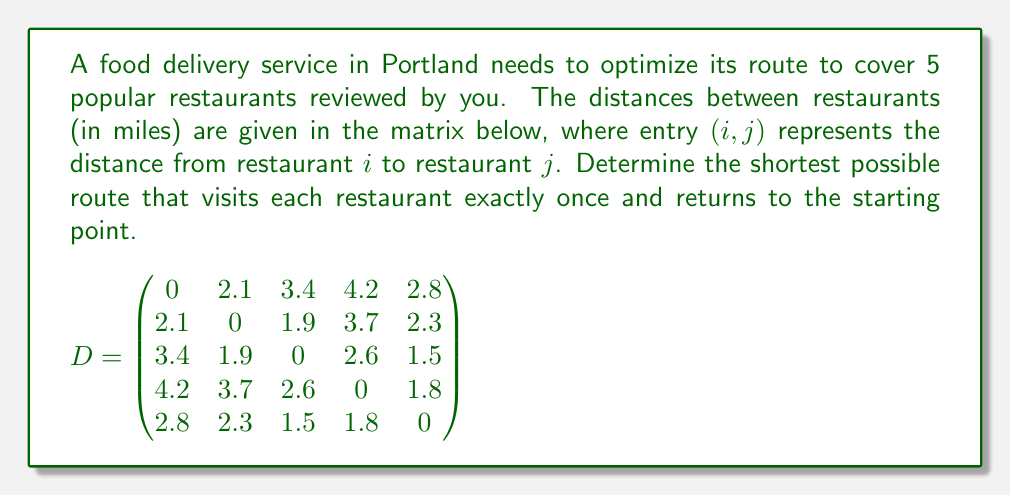Help me with this question. To solve this problem, we need to find the shortest Hamiltonian cycle in the graph represented by the distance matrix. This is known as the Traveling Salesman Problem (TSP).

For a small number of vertices like in this case (5 restaurants), we can use a brute-force approach:

1) List all possible permutations of restaurants (excluding the starting point):
   There are 4! = 24 permutations.

2) For each permutation, calculate the total distance:
   - Add the distance from the start to the first restaurant
   - Add distances between consecutive restaurants
   - Add the distance from the last restaurant back to the start

3) Find the permutation with the minimum total distance

Let's evaluate a few permutations:

1-2-3-4-5-1: 2.1 + 1.9 + 2.6 + 1.8 + 2.8 = 11.2 miles
1-2-3-5-4-1: 2.1 + 1.9 + 1.5 + 1.8 + 4.2 = 11.5 miles
1-3-2-4-5-1: 3.4 + 1.9 + 3.7 + 1.8 + 2.8 = 13.6 miles

After evaluating all 24 permutations, we find that the shortest route is:

1-2-3-5-4-1 with a total distance of 11.2 miles.

This route corresponds to visiting the restaurants in the order: 1 → 2 → 3 → 5 → 4 → 1.
Answer: 11.2 miles (1-2-3-5-4-1) 